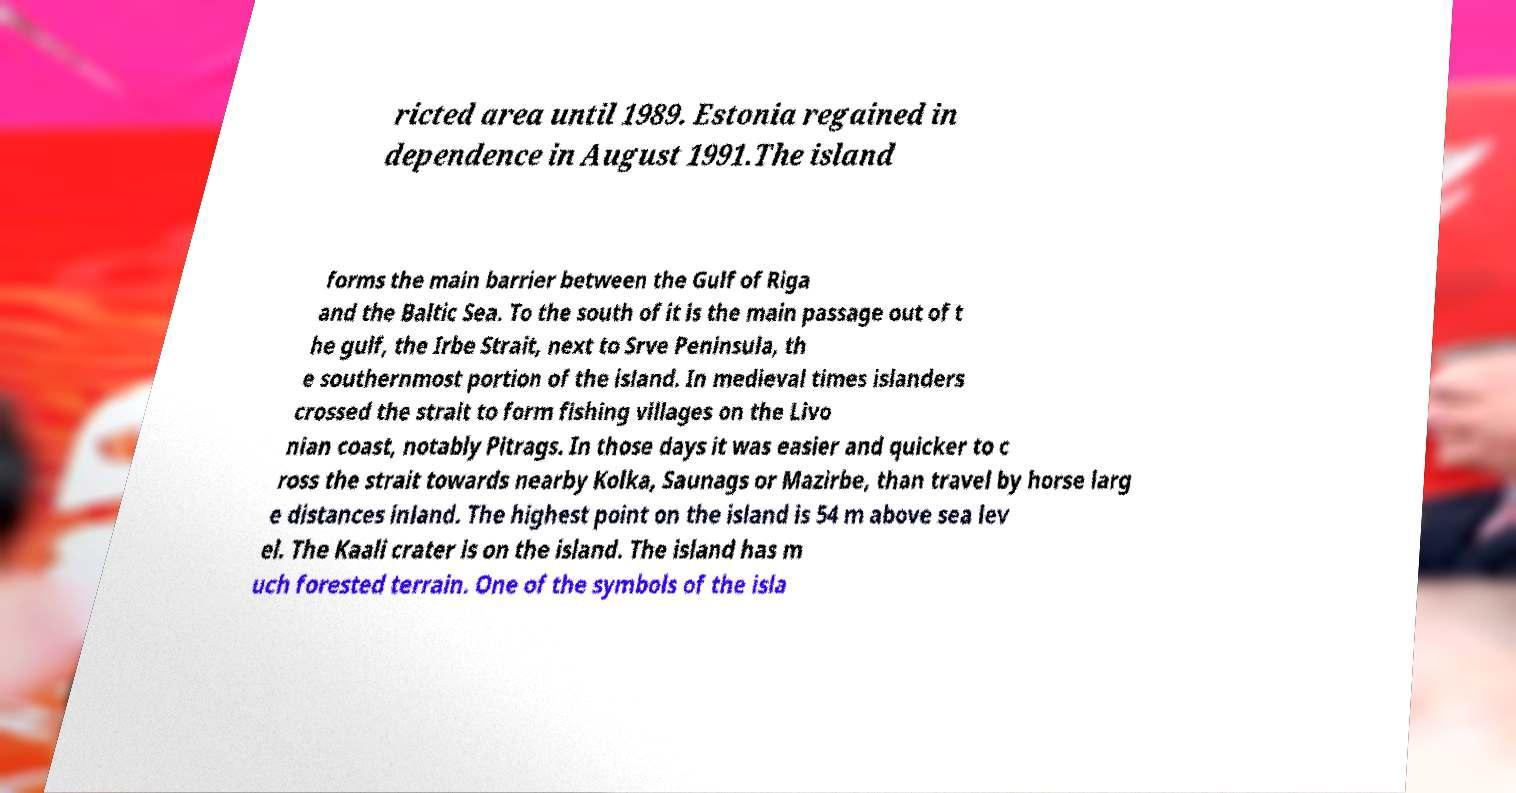Please read and relay the text visible in this image. What does it say? ricted area until 1989. Estonia regained in dependence in August 1991.The island forms the main barrier between the Gulf of Riga and the Baltic Sea. To the south of it is the main passage out of t he gulf, the Irbe Strait, next to Srve Peninsula, th e southernmost portion of the island. In medieval times islanders crossed the strait to form fishing villages on the Livo nian coast, notably Pitrags. In those days it was easier and quicker to c ross the strait towards nearby Kolka, Saunags or Mazirbe, than travel by horse larg e distances inland. The highest point on the island is 54 m above sea lev el. The Kaali crater is on the island. The island has m uch forested terrain. One of the symbols of the isla 